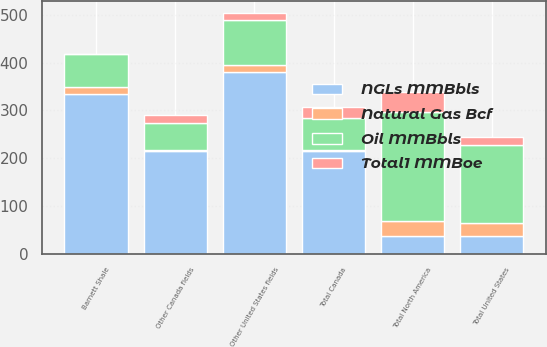Convert chart to OTSL. <chart><loc_0><loc_0><loc_500><loc_500><stacked_bar_chart><ecel><fcel>Barnett Shale<fcel>Other United States fields<fcel>Total United States<fcel>Other Canada fields<fcel>Total Canada<fcel>Total North America<nl><fcel>Total1 MMBoe<fcel>1<fcel>15<fcel>16<fcel>16<fcel>25<fcel>41<nl><fcel>NGLs MMBbls<fcel>335<fcel>381<fcel>36.5<fcel>214<fcel>214<fcel>36.5<nl><fcel>Natural Gas Bcf<fcel>13<fcel>15<fcel>28<fcel>4<fcel>4<fcel>32<nl><fcel>Oil MMBbls<fcel>70<fcel>93<fcel>163<fcel>56<fcel>65<fcel>228<nl></chart> 